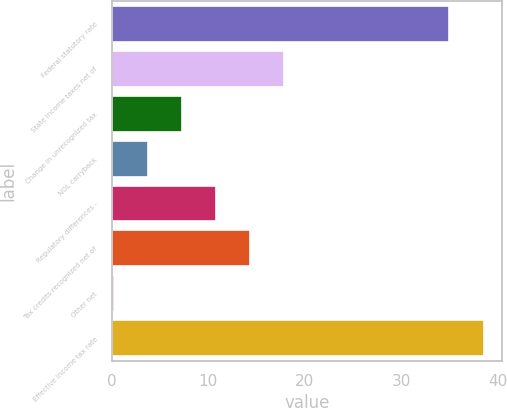Convert chart to OTSL. <chart><loc_0><loc_0><loc_500><loc_500><bar_chart><fcel>Federal statutory rate<fcel>State income taxes net of<fcel>Change in unrecognized tax<fcel>NOL carryback<fcel>Regulatory differences -<fcel>Tax credits recognized net of<fcel>Other net<fcel>Effective income tax rate<nl><fcel>35<fcel>17.85<fcel>7.26<fcel>3.73<fcel>10.79<fcel>14.32<fcel>0.2<fcel>38.53<nl></chart> 